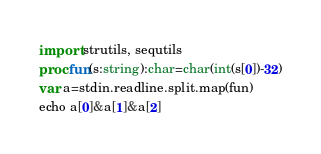Convert code to text. <code><loc_0><loc_0><loc_500><loc_500><_Nim_>import strutils, sequtils
proc fun(s:string):char=char(int(s[0])-32)
var a=stdin.readline.split.map(fun)
echo a[0]&a[1]&a[2]</code> 